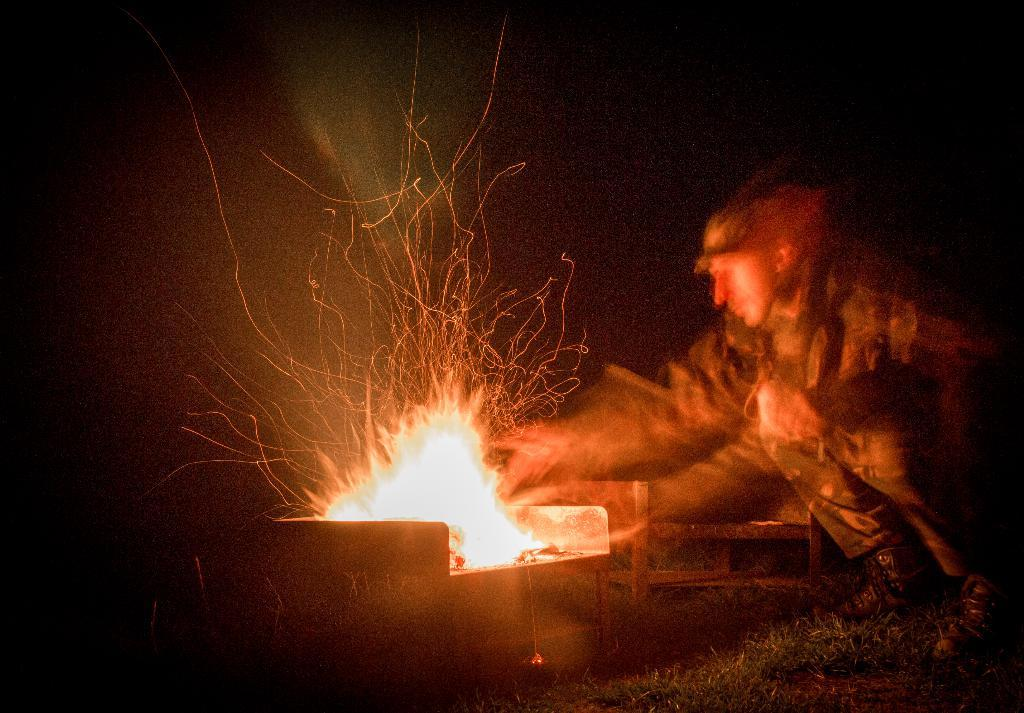Who is present in the image? There is a person in the image. What is the person doing in the image? The person is sitting on the grass and making a fire with twigs. What is the person wearing in the image? The person is wearing an army uniform and a cap. What is the time of day in the image? The scene takes place at night. What type of oatmeal is the person eating in the image? There is no oatmeal present in the image; the person is making a fire with twigs. How does the person tie a knot in the image? There is no mention of a knot in the image; the person is making a fire with twigs. 